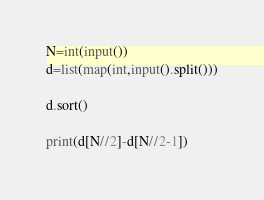Convert code to text. <code><loc_0><loc_0><loc_500><loc_500><_Python_>N=int(input())
d=list(map(int,input().split()))

d.sort()

print(d[N//2]-d[N//2-1])</code> 